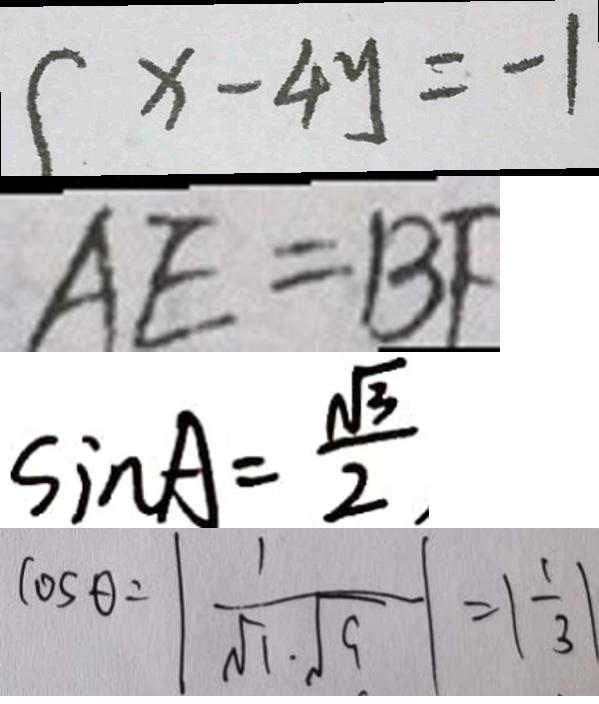Convert formula to latex. <formula><loc_0><loc_0><loc_500><loc_500>x - 4 y = - 1 
 A E = B F 
 \sin A = \frac { \sqrt { 3 } } { 2 } , 
 \cos \theta = \vert \frac { 1 } { \sqrt { 1 } \cdot \sqrt { 9 } } \vert = \vert \frac { 1 } { 3 } \vert</formula> 